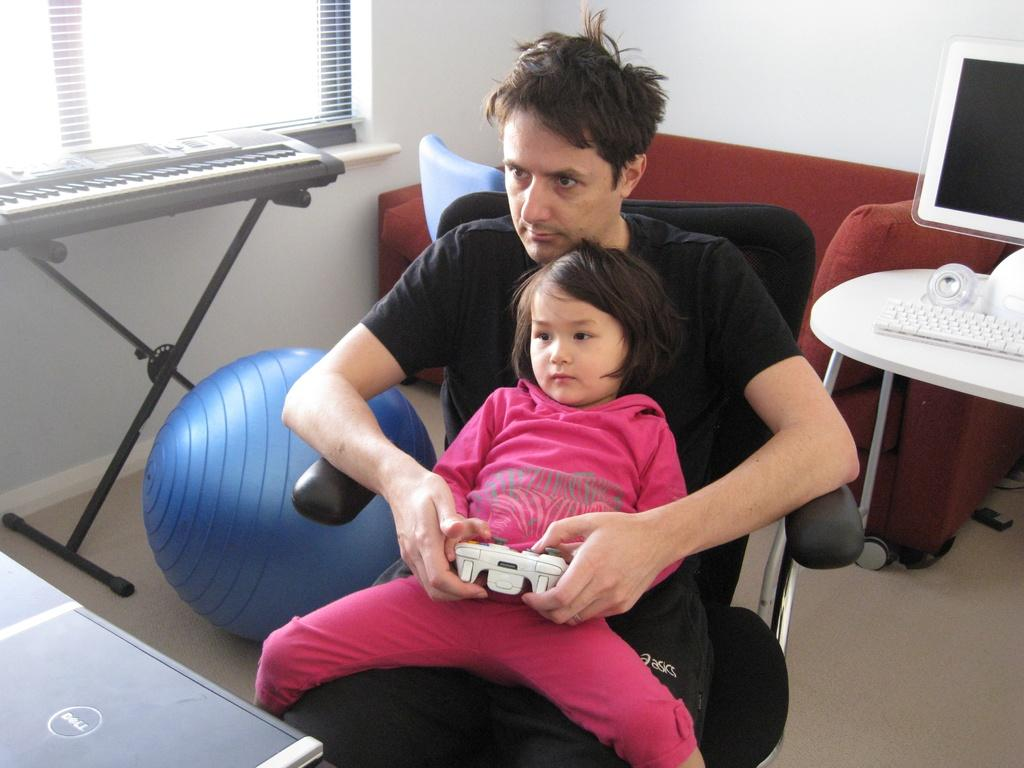What musical instrument can be found in the room? There is a piano keyboard in the room. What type of furniture is in the room for seating? There is a couch and two chairs in the room. What is on the table in the room? There is a keyboard and a monitor on the table. What object is not related to technology or music in the room? There is a ball in the room. How many people are present in the room? Two persons are sitting on chairs in the room. Can you see any smoke coming from the piano keyboard in the room? There is no smoke present in the image, and the piano keyboard is not producing any smoke. Is there a turkey on the table in the room? There is no turkey mentioned in the provided facts; the table only contains a keyboard and a monitor. 